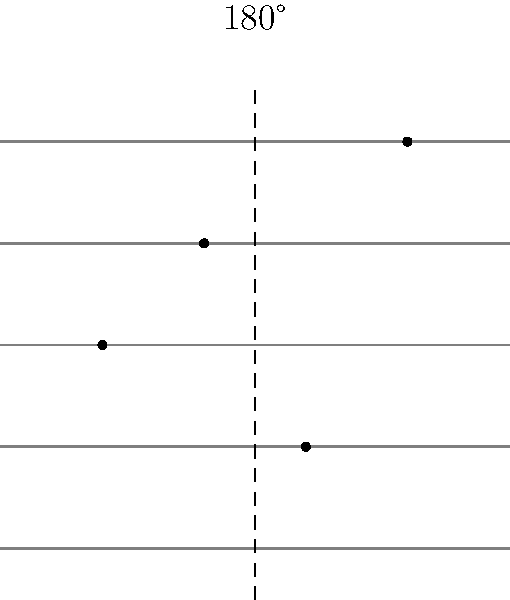In composing a modern hymn, you want to create symmetry in your musical notation. Given the staff with four quarter notes as shown, how many of these notes will coincide with their original positions after a 180° rotation around the vertical axis passing through the center of the staff? To solve this problem, let's follow these steps:

1. Identify the axis of rotation:
   The vertical dashed line passing through the center of the staff (between the 2nd and 3rd measure) is the axis of rotation.

2. Understand the effect of 180° rotation:
   A 180° rotation around a vertical axis will flip the notes horizontally, keeping their vertical positions (pitch) the same.

3. Analyze each note's position after rotation:
   - Note 1 (leftmost): Will move to the rightmost position, not coinciding with any original note.
   - Note 2: Will move to the position of Note 3, not coinciding with its original position.
   - Note 3: Will move to the position of Note 2, not coinciding with its original position.
   - Note 4 (rightmost): Will move to the leftmost position, not coinciding with any original note.

4. Count coinciding notes:
   After rotation, none of the notes will be in their original positions.

Therefore, 0 notes will coincide with their original positions after the 180° rotation.
Answer: 0 notes 